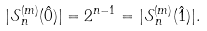Convert formula to latex. <formula><loc_0><loc_0><loc_500><loc_500>| \mathcal { S } _ { n } ^ { ( m ) } ( \hat { 0 } ) | = 2 ^ { n - 1 } = | \mathcal { S } _ { n } ^ { ( m ) } ( \hat { 1 } ) | .</formula> 